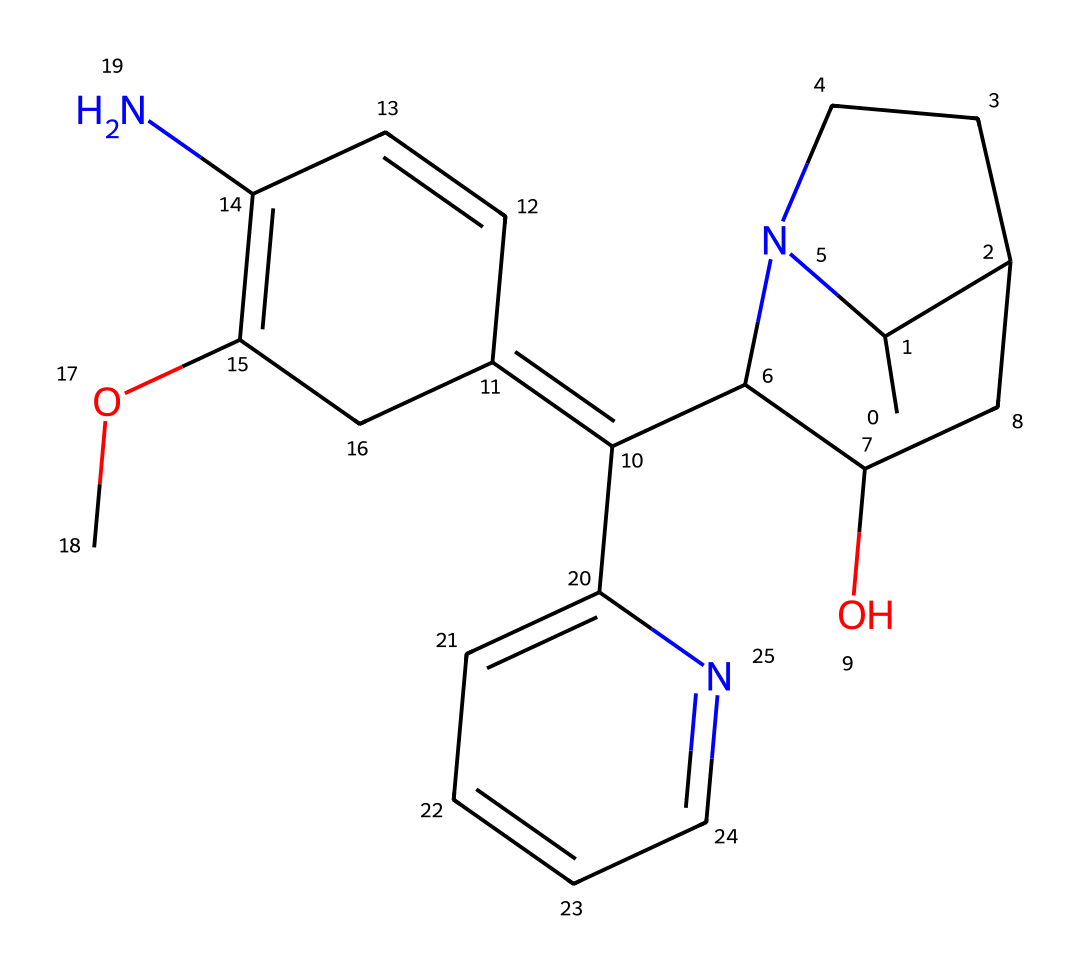What is the molecular formula of quinine? To determine the molecular formula, we need to count the number of each type of atom present in the structure. The given SMILES representation indicates a combination of carbon (C), hydrogen (H), nitrogen (N), and oxygen (O) atoms. By analyzing the structure, we find it contains 24 carbon atoms, 26 hydrogen atoms, 1 nitrogen atom, and 1 oxygen atom. Therefore, the molecular formula is C24H26N2O.
Answer: C24H26N2O How many rings are present in the structure of quinine? By examining the chemical structure, we can visually identify the cyclic portions. There are a total of three rings: one six-membered ring and two five-membered rings. Thus, the total number of rings is 3.
Answer: 3 What functional groups are present in quinine? In the structure, we can identify the presence of an alcohol (hydroxyl, -OH) and an ether (-O-) functional group among other features typical for alkaloids. These functional groups contribute to the properties of quinine.
Answer: alcohol and ether Which part of the molecule makes quinine an alkaloid? Alkaloids, which often contain nitrogen, can be recognized in this molecule due to the nitrogen atoms present in the structure. Specifically, quinine has two nitrogen atoms in its structure, which reinforces its classification as an alkaloid.
Answer: nitrogen atoms What is the significance of the nitrogen atom in quinine? The nitrogen atom contributes to the pharmacological activity of quinine, particularly in its mechanism of action against malaria. The presence of nitrogen affects both the solubility and the biological interaction of the compound with its target, such as malaria parasites.
Answer: pharmacological activity Which portion of the molecule contributes to its bitter taste? The presence of nitrogen atoms, which often correlate with the taste of alkaloids, plays a key role in giving quinine its notably bitter taste. The cyclic structure of the alkaloid itself also contributes to the taste perception.
Answer: nitrogen atoms 